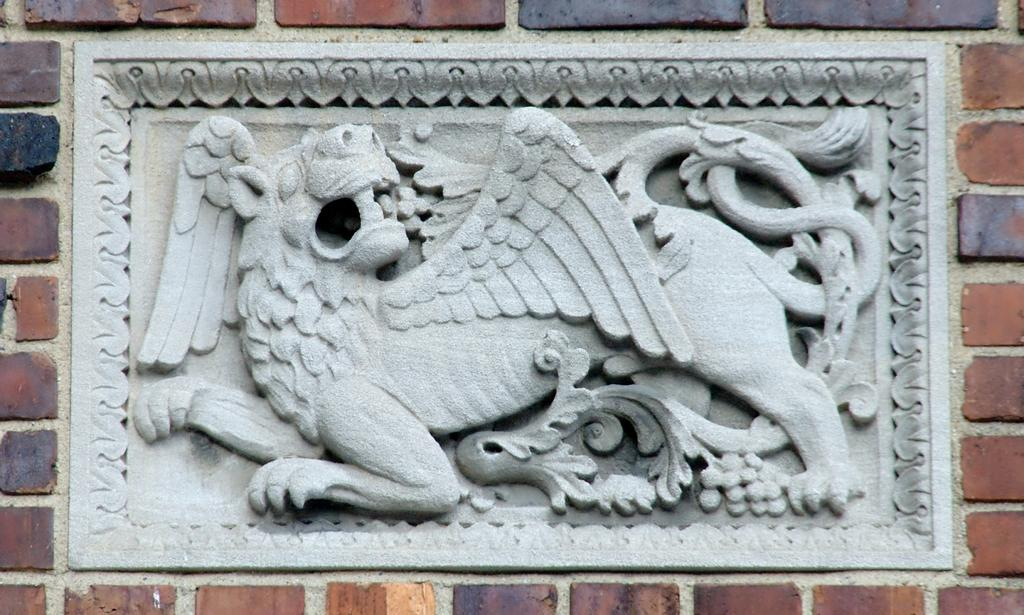What is present on the wall in the image? There is a sculpture on the wall in the image. Can you describe the sculpture on the wall? Unfortunately, the provided facts do not include a description of the sculpture. How many spiders are crawling on the sculpture in the image? There is no mention of spiders in the image, so it is not possible to answer that question. In which room of the house is the sculpture located in the image? The provided facts do not specify the room or location of the sculpture in the image. What type of bird is perched on the sculpture in the image? There is no bird, such as a wren, present on the sculpture in the image. 